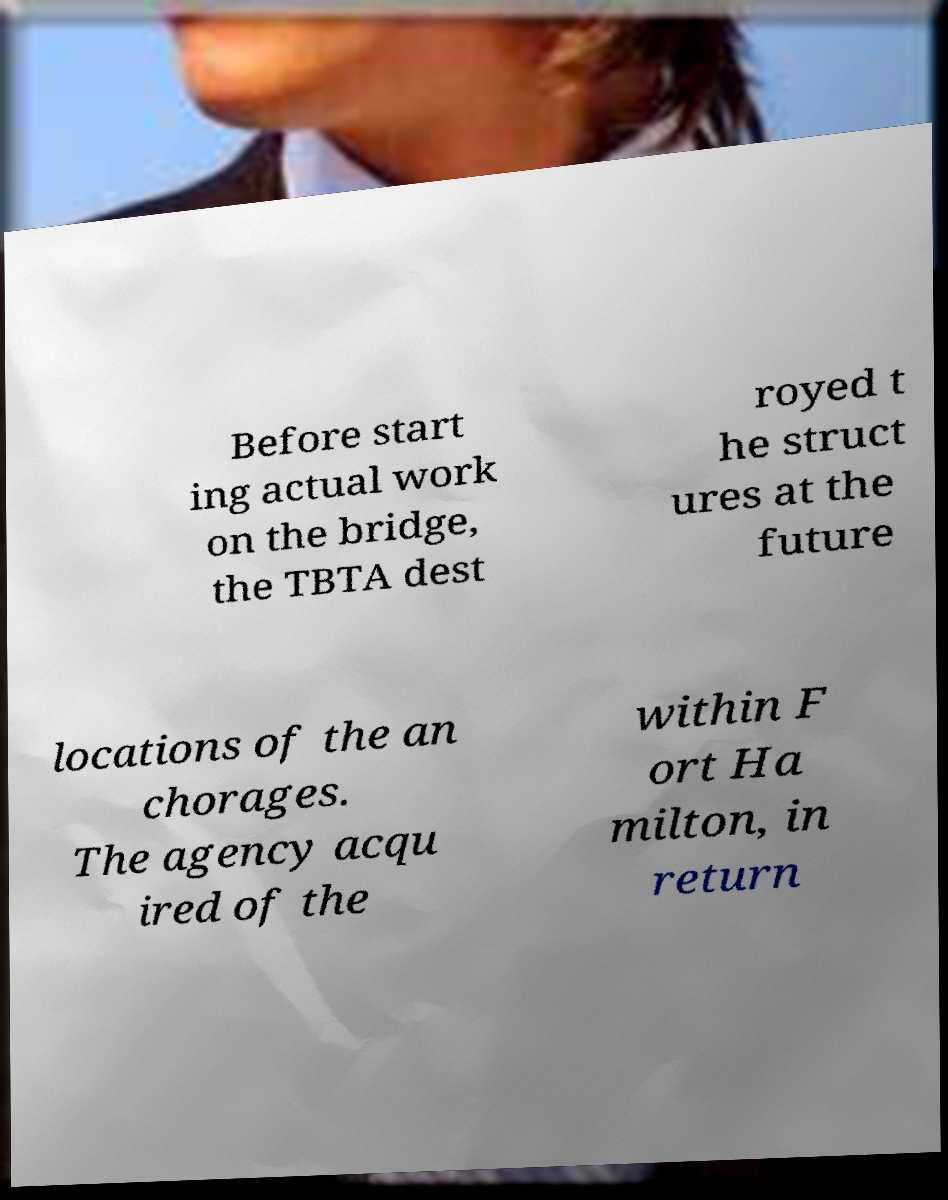What messages or text are displayed in this image? I need them in a readable, typed format. Before start ing actual work on the bridge, the TBTA dest royed t he struct ures at the future locations of the an chorages. The agency acqu ired of the within F ort Ha milton, in return 